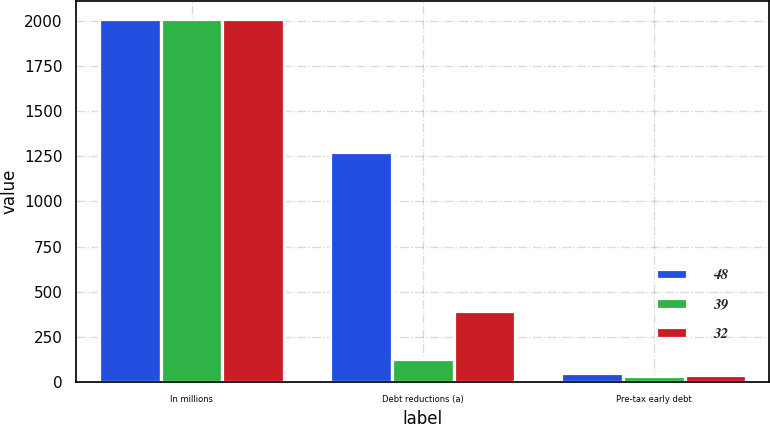<chart> <loc_0><loc_0><loc_500><loc_500><stacked_bar_chart><ecel><fcel>In millions<fcel>Debt reductions (a)<fcel>Pre-tax early debt<nl><fcel>48<fcel>2012<fcel>1272<fcel>48<nl><fcel>39<fcel>2011<fcel>129<fcel>32<nl><fcel>32<fcel>2010<fcel>393<fcel>39<nl></chart> 